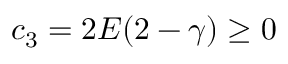Convert formula to latex. <formula><loc_0><loc_0><loc_500><loc_500>c _ { 3 } = 2 E ( 2 - \gamma ) \geq 0</formula> 